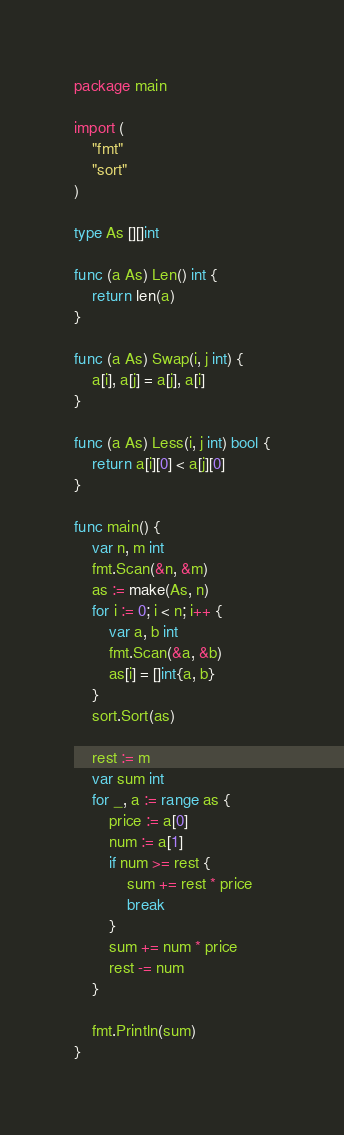Convert code to text. <code><loc_0><loc_0><loc_500><loc_500><_Go_>package main

import (
    "fmt"
    "sort"
)

type As [][]int

func (a As) Len() int {
    return len(a)
}

func (a As) Swap(i, j int) {
    a[i], a[j] = a[j], a[i]
}

func (a As) Less(i, j int) bool {
    return a[i][0] < a[j][0]
}

func main() {
    var n, m int
    fmt.Scan(&n, &m)
    as := make(As, n)
    for i := 0; i < n; i++ {
        var a, b int
        fmt.Scan(&a, &b)
        as[i] = []int{a, b}
    }
    sort.Sort(as)

    rest := m
    var sum int
    for _, a := range as {
        price := a[0]
        num := a[1]
        if num >= rest {
            sum += rest * price
            break
        }
        sum += num * price
        rest -= num
    }

    fmt.Println(sum)
}
</code> 